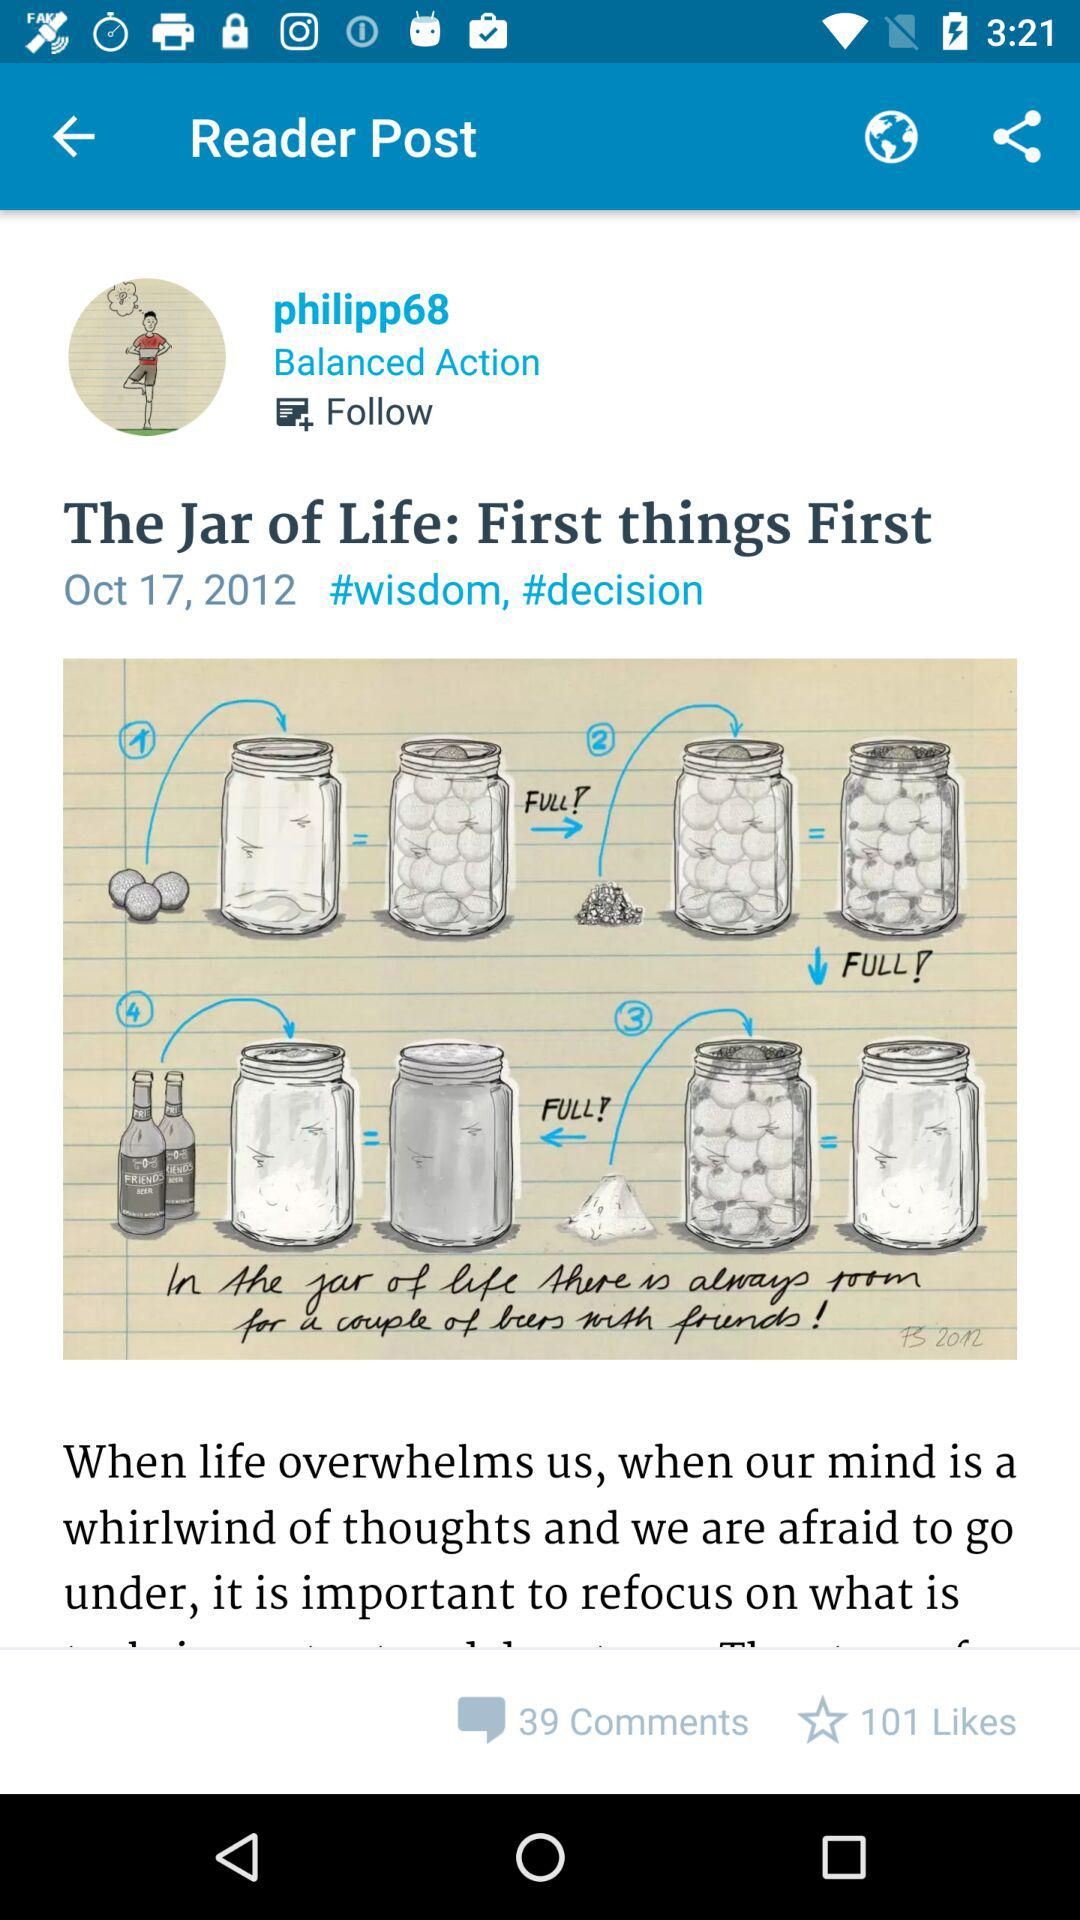At what time was "The Jar of Life: First things First" published?
When the provided information is insufficient, respond with <no answer>. <no answer> 